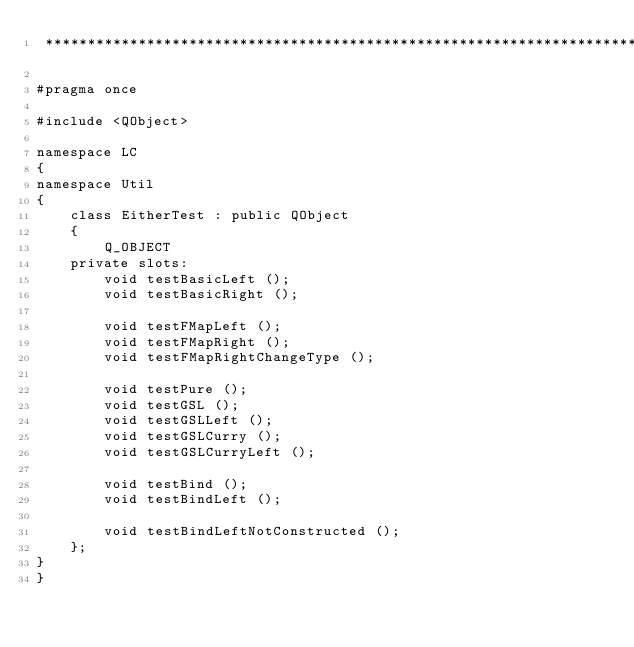Convert code to text. <code><loc_0><loc_0><loc_500><loc_500><_C_> **********************************************************************/

#pragma once

#include <QObject>

namespace LC
{
namespace Util
{
	class EitherTest : public QObject
	{
		Q_OBJECT
	private slots:
		void testBasicLeft ();
		void testBasicRight ();

		void testFMapLeft ();
		void testFMapRight ();
		void testFMapRightChangeType ();

		void testPure ();
		void testGSL ();
		void testGSLLeft ();
		void testGSLCurry ();
		void testGSLCurryLeft ();

		void testBind ();
		void testBindLeft ();

		void testBindLeftNotConstructed ();
	};
}
}
</code> 